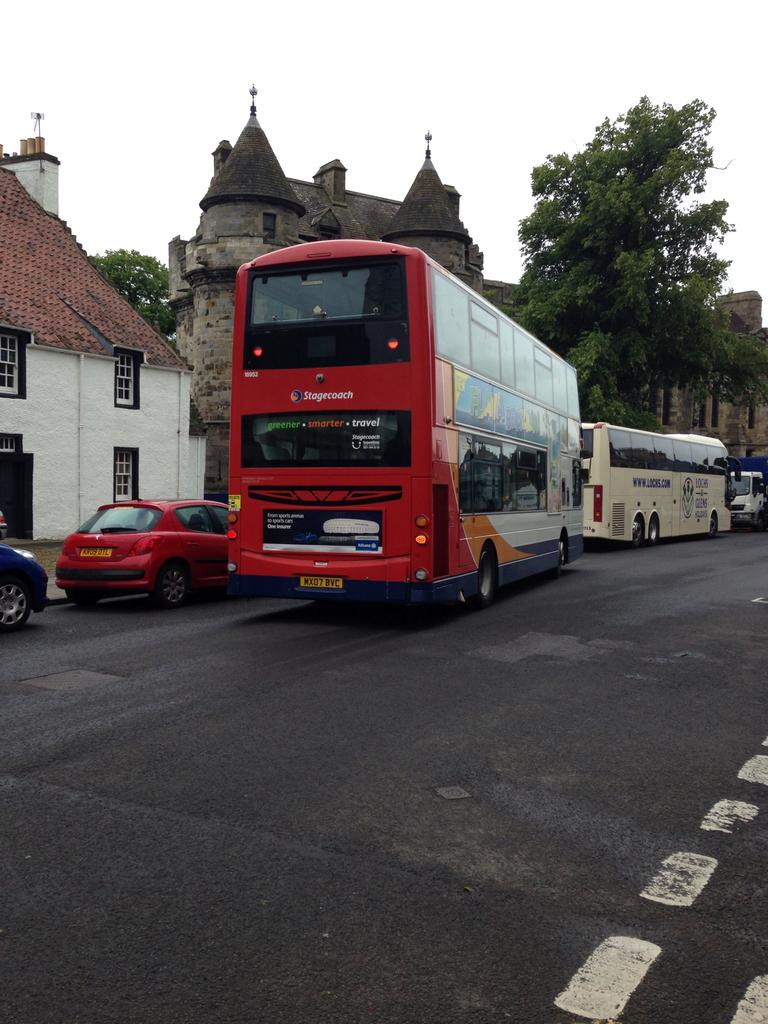<image>
Present a compact description of the photo's key features. A red Stagecoach double decker bus on a street 